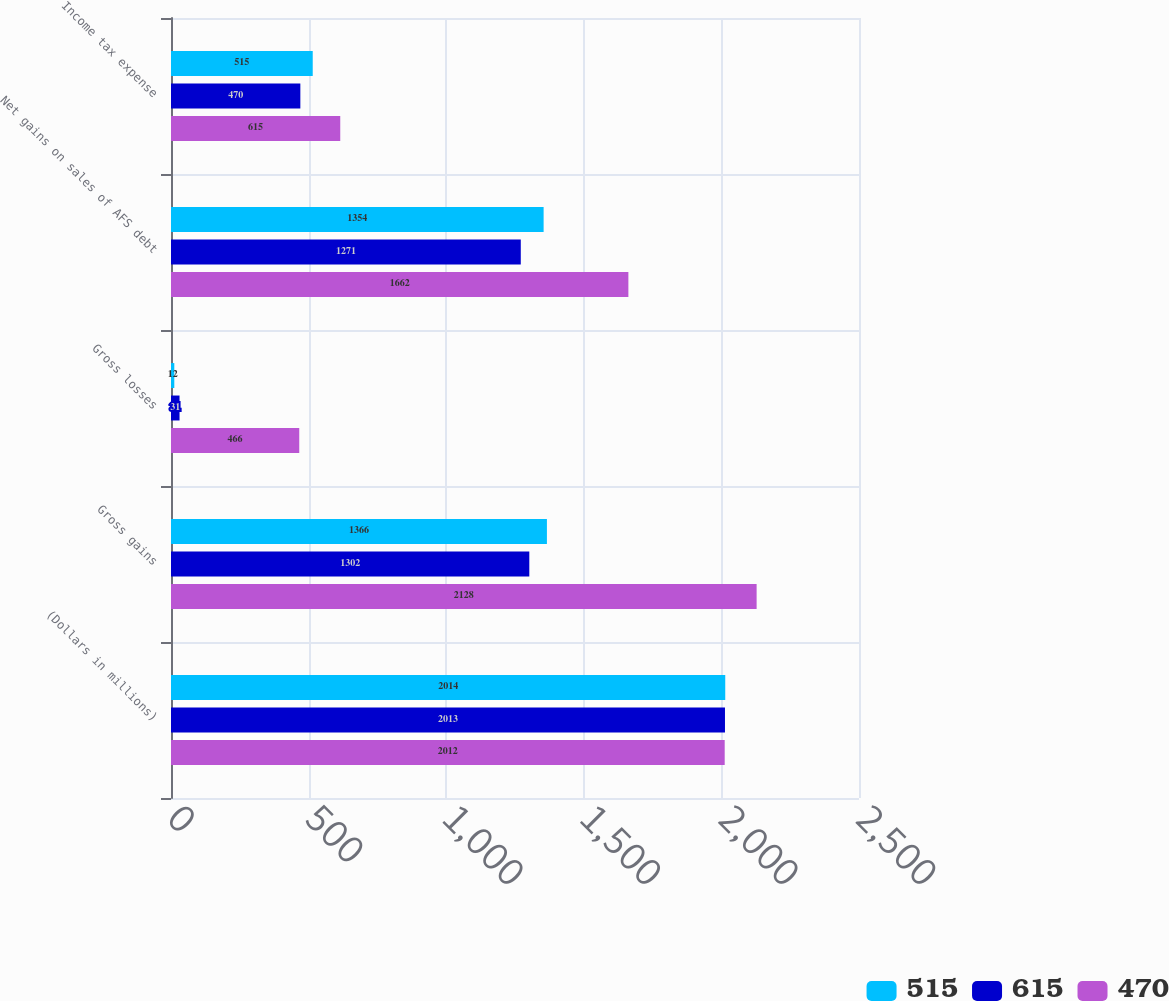<chart> <loc_0><loc_0><loc_500><loc_500><stacked_bar_chart><ecel><fcel>(Dollars in millions)<fcel>Gross gains<fcel>Gross losses<fcel>Net gains on sales of AFS debt<fcel>Income tax expense<nl><fcel>515<fcel>2014<fcel>1366<fcel>12<fcel>1354<fcel>515<nl><fcel>615<fcel>2013<fcel>1302<fcel>31<fcel>1271<fcel>470<nl><fcel>470<fcel>2012<fcel>2128<fcel>466<fcel>1662<fcel>615<nl></chart> 